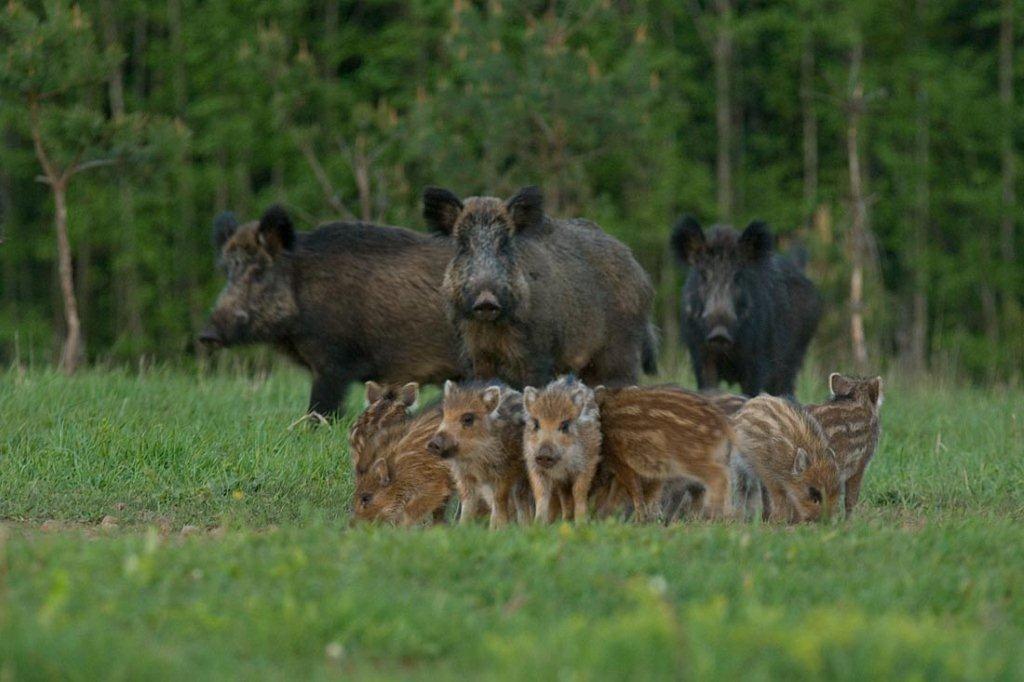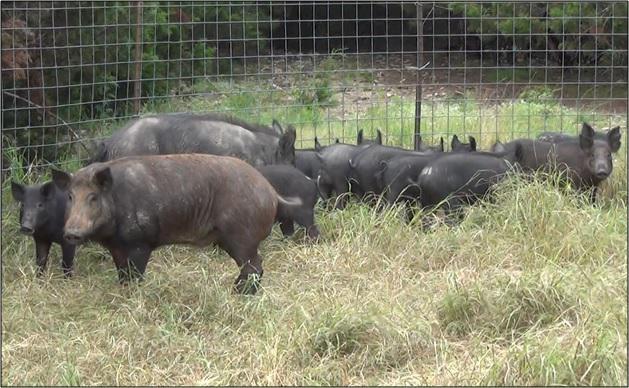The first image is the image on the left, the second image is the image on the right. Given the left and right images, does the statement "All boars in the right image are facing right." hold true? Answer yes or no. No. The first image is the image on the left, the second image is the image on the right. Analyze the images presented: Is the assertion "An image contains multiple dark adult boars, and at least seven striped juvenile pigs." valid? Answer yes or no. Yes. 